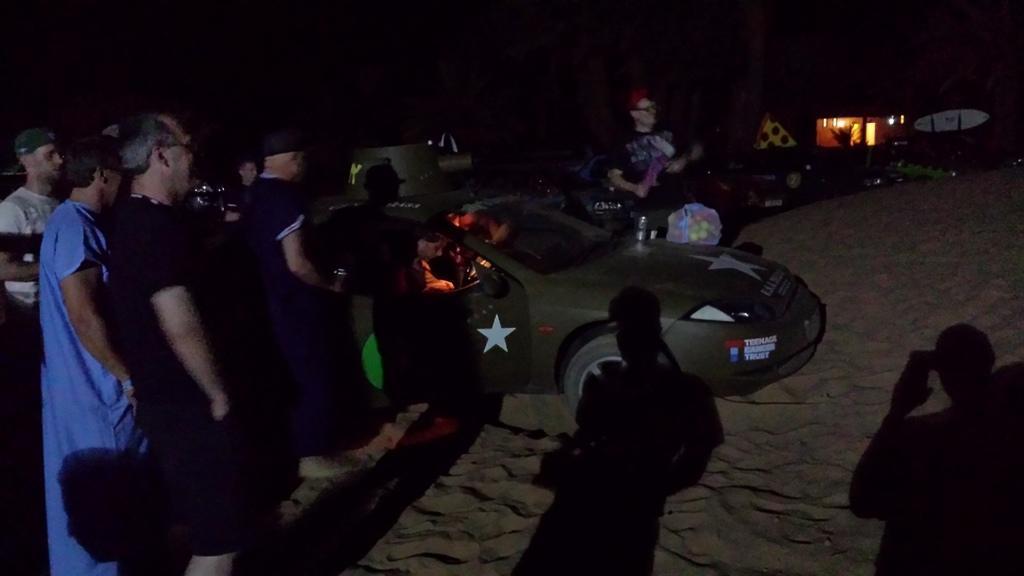How would you summarize this image in a sentence or two? In this image there is a vehicle, around the vehicle there are a few people standing on the surface of the sand, there is a building and a few other objects. In the background is dark. 